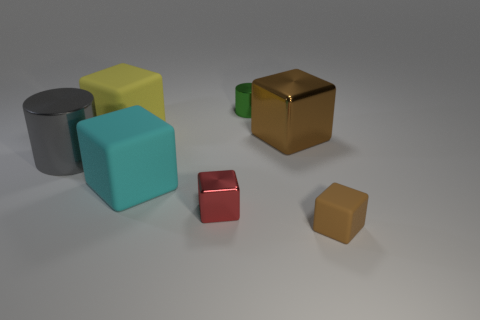There is a cylinder in front of the tiny green metallic thing; what is its material? The cylinder in front of the tiny green metallic object appears to have a matte finish suggestive of a non-metallic material, possibly plastic or ceramic. 